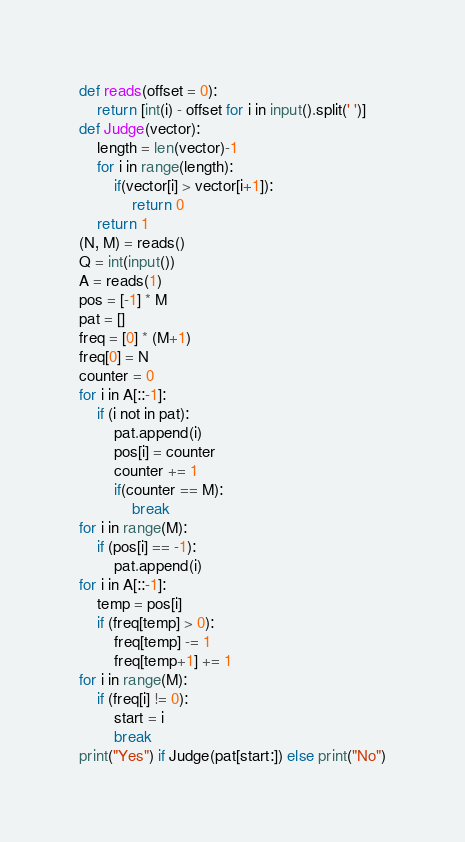<code> <loc_0><loc_0><loc_500><loc_500><_Python_>def reads(offset = 0):
	return [int(i) - offset for i in input().split(' ')]
def Judge(vector):
	length = len(vector)-1
	for i in range(length):
		if(vector[i] > vector[i+1]):		
			return 0
	return 1
(N, M) = reads()
Q = int(input())
A = reads(1)
pos = [-1] * M
pat = []
freq = [0] * (M+1)
freq[0] = N
counter = 0
for i in A[::-1]:
	if (i not in pat):
		pat.append(i)
		pos[i] = counter
		counter += 1
		if(counter == M):
			break
for i in range(M):
	if (pos[i] == -1):
		pat.append(i)
for i in A[::-1]:
	temp = pos[i]
	if (freq[temp] > 0):
		freq[temp] -= 1
		freq[temp+1] += 1
for i in range(M):
	if (freq[i] != 0):
		start = i
		break
print("Yes") if Judge(pat[start:]) else print("No")</code> 